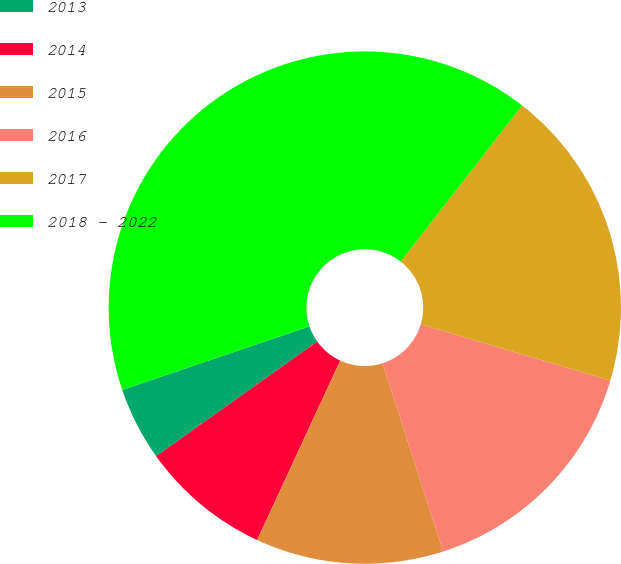Convert chart. <chart><loc_0><loc_0><loc_500><loc_500><pie_chart><fcel>2013<fcel>2014<fcel>2015<fcel>2016<fcel>2017<fcel>2018 - 2022<nl><fcel>4.64%<fcel>8.25%<fcel>11.85%<fcel>15.46%<fcel>19.07%<fcel>40.73%<nl></chart> 